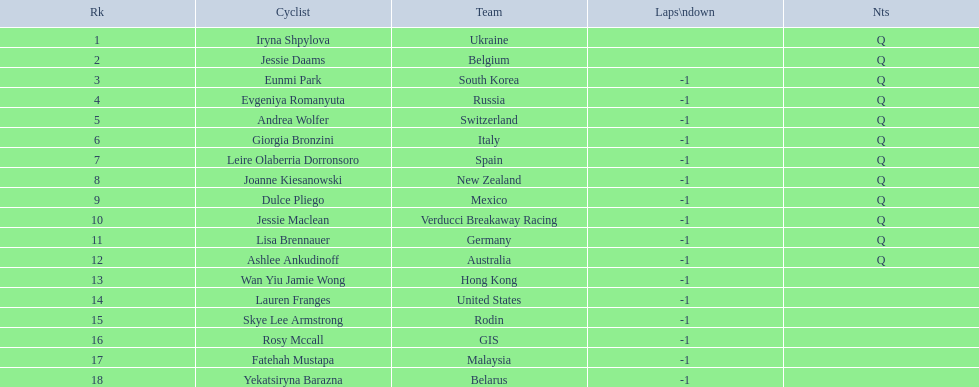What is the number rank of belgium? 2. 